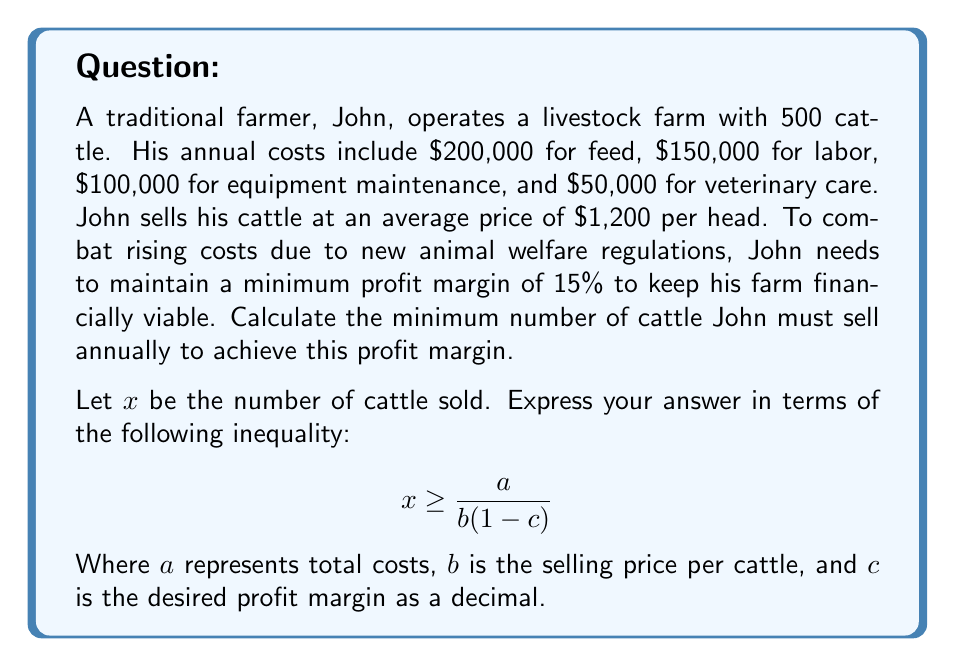Provide a solution to this math problem. To solve this problem, we'll follow these steps:

1) First, let's calculate the total annual costs:
   $$ \text{Total Costs} = 200,000 + 150,000 + 100,000 + 50,000 = \$500,000 $$

2) Now, we need to set up an inequality where the revenue minus costs is greater than or equal to the desired profit margin times the revenue:
   $$ 1200x - 500,000 \geq 0.15(1200x) $$

3) Simplify the right side of the inequality:
   $$ 1200x - 500,000 \geq 180x $$

4) Subtract 180x from both sides:
   $$ 1020x - 500,000 \geq 0 $$

5) Add 500,000 to both sides:
   $$ 1020x \geq 500,000 $$

6) Divide both sides by 1020:
   $$ x \geq \frac{500,000}{1020} \approx 490.20 $$

7) Since we can't sell a fraction of a cattle, we round up to the nearest whole number:
   $$ x \geq 491 $$

8) To express this in the required form $x \geq \frac{a}{b(1-c)}$:
   $a = 500,000$ (total costs)
   $b = 1,200$ (selling price per cattle)
   $c = 0.15$ (desired profit margin as a decimal)

   $$ x \geq \frac{500,000}{1200(1-0.15)} = \frac{500,000}{1020} $$

This is equivalent to our solution in step 6.
Answer: John must sell at least 491 cattle annually to maintain a 15% profit margin. The inequality can be expressed as:

$$ x \geq \frac{500,000}{1200(1-0.15)} $$

Where $x$ is the number of cattle sold. 